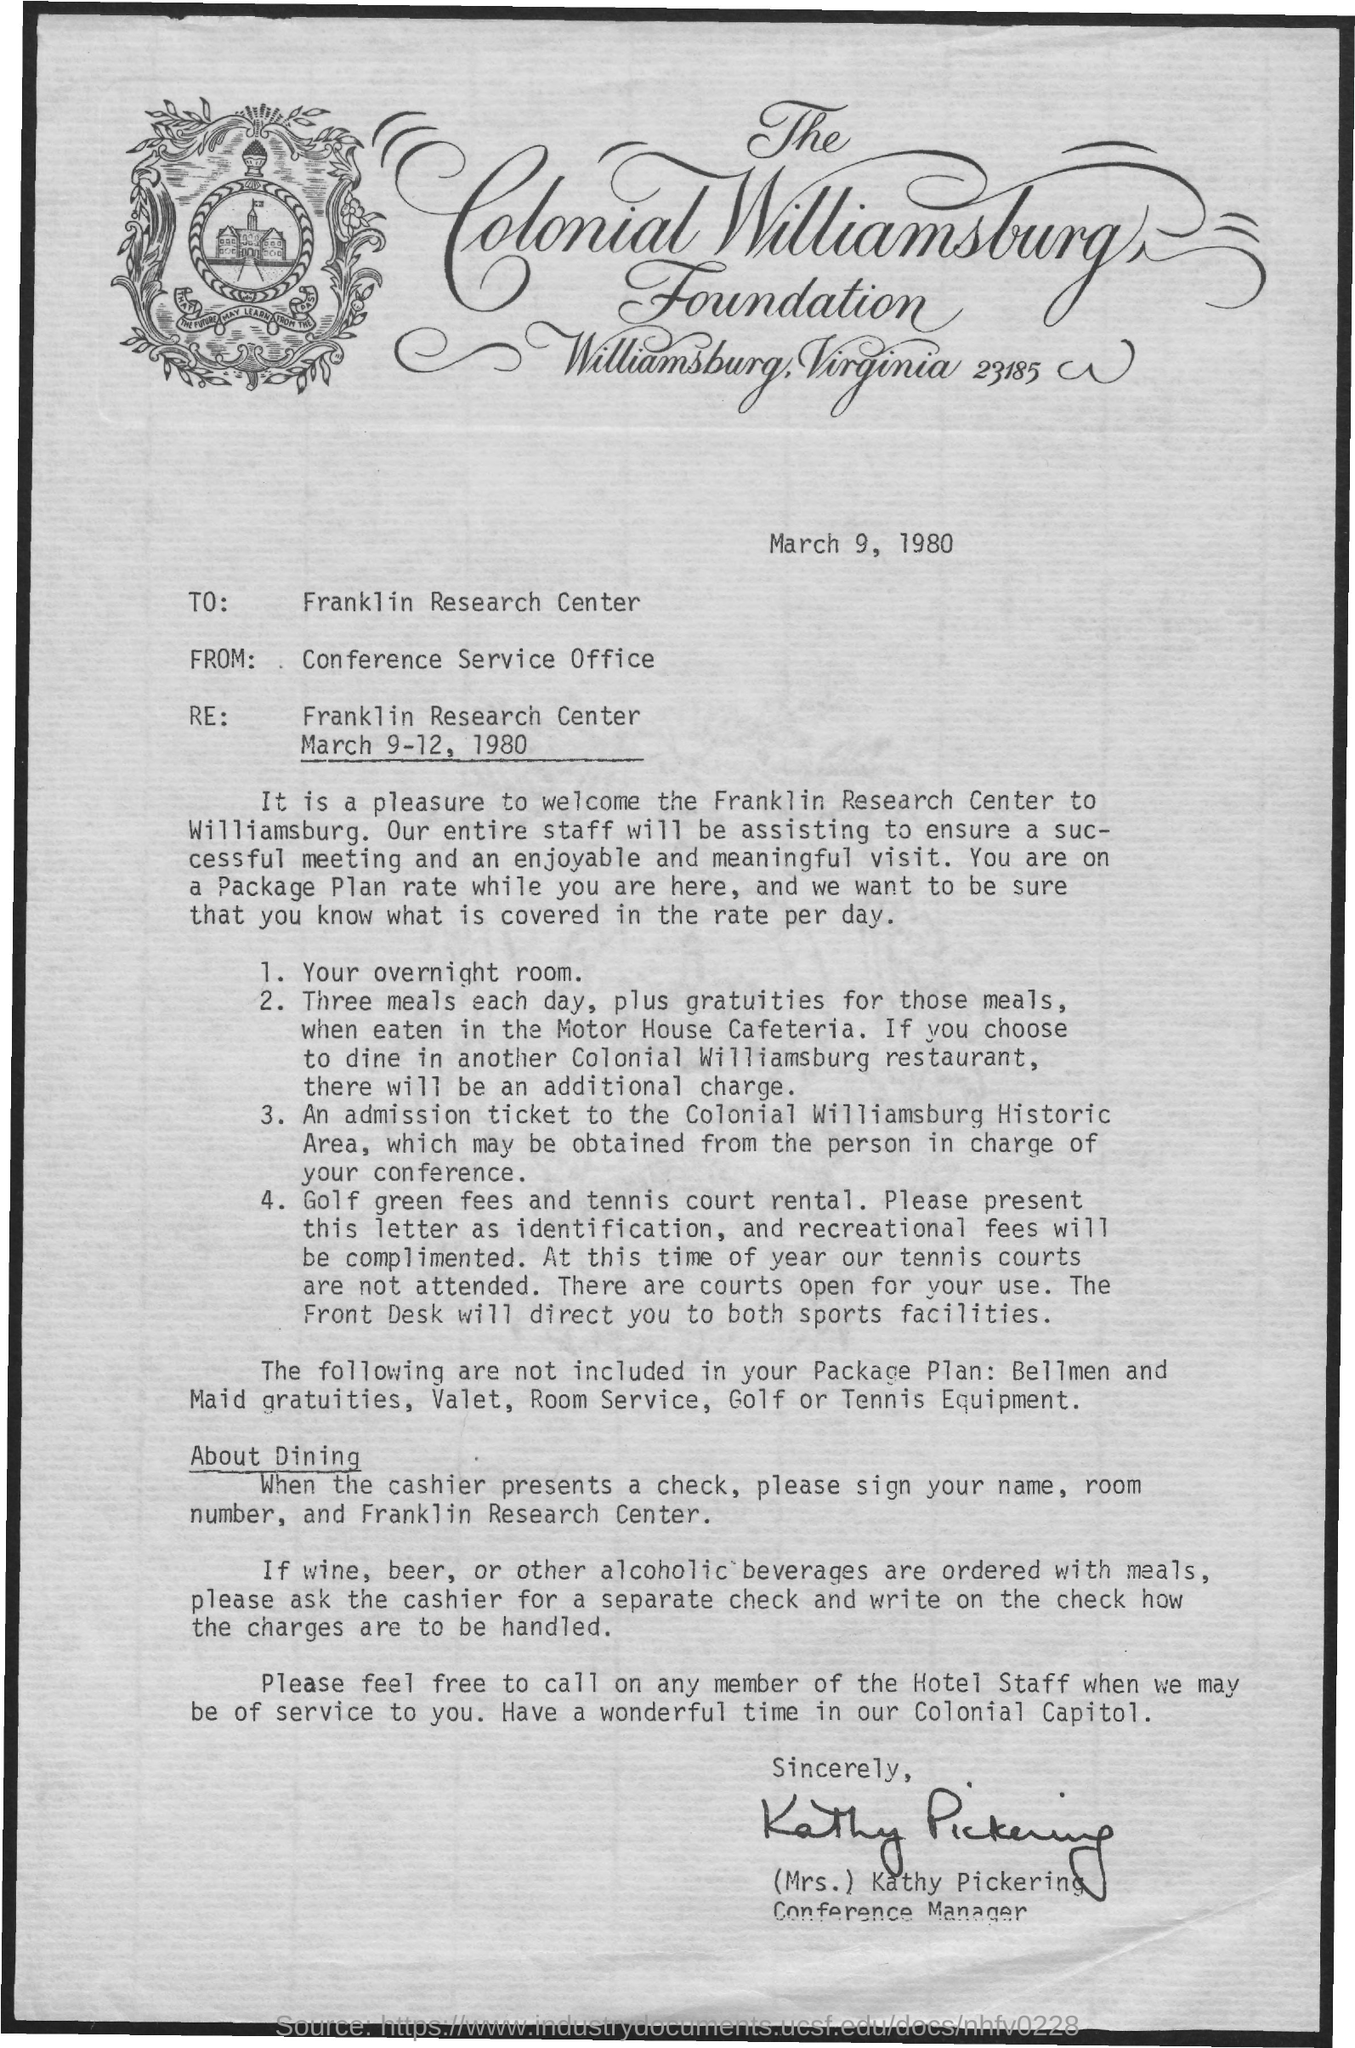What is the address of the colonial williamsburg foundation?
Keep it short and to the point. Williamsburg, Virginia 23185. What is the to address in letter?
Offer a very short reply. Franklin Research Center. The letter is dated on?
Give a very brief answer. March 9, 1980. Who is the conference manager?
Provide a short and direct response. (Mrs.) Kathy Pickering. 